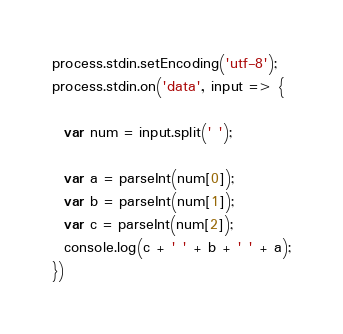<code> <loc_0><loc_0><loc_500><loc_500><_JavaScript_>process.stdin.setEncoding('utf-8');
process.stdin.on('data', input => {

  var num = input.split(' ');

  var a = parseInt(num[0]);
  var b = parseInt(num[1]);
  var c = parseInt(num[2]);
  console.log(c + ' ' + b + ' ' + a);
}) 
</code> 